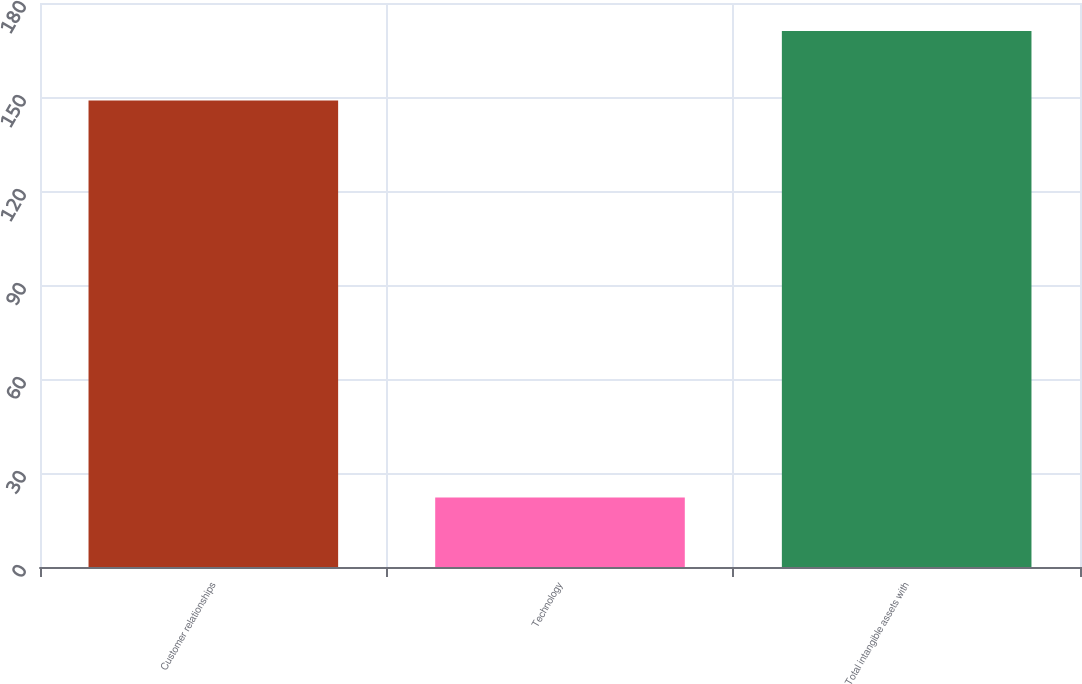Convert chart. <chart><loc_0><loc_0><loc_500><loc_500><bar_chart><fcel>Customer relationships<fcel>Technology<fcel>Total intangible assets with<nl><fcel>148.9<fcel>22.2<fcel>171.1<nl></chart> 